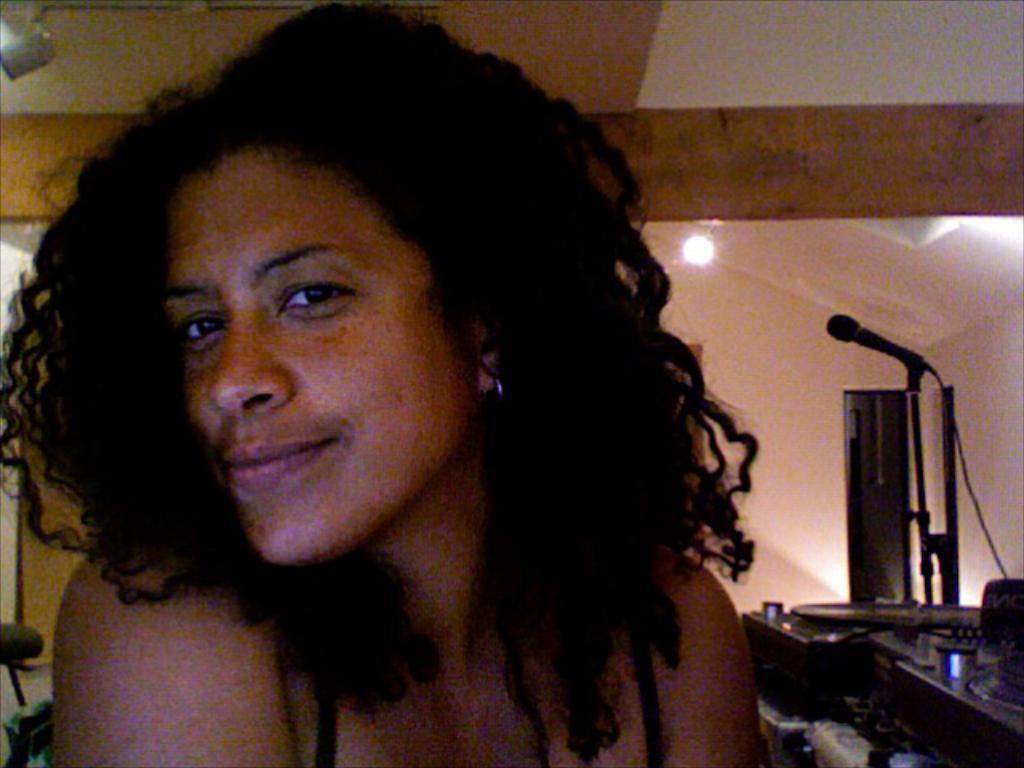In one or two sentences, can you explain what this image depicts? In this image, we can see a woman, on the right side, we can see a microphone and some objects. We can see the walls, roof and the lights. 